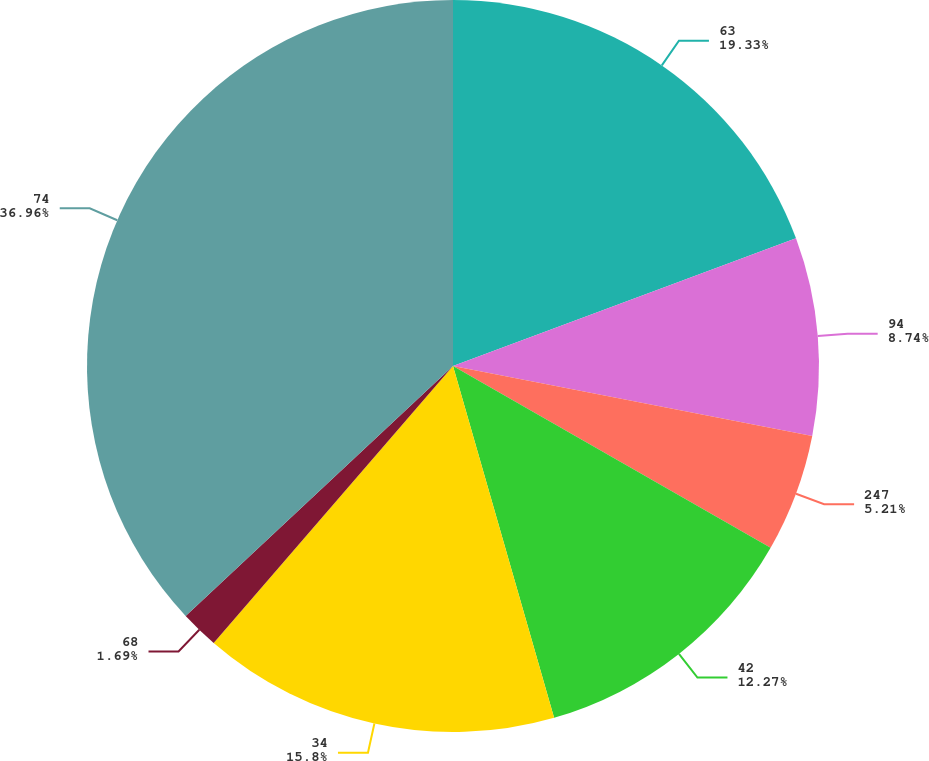Convert chart to OTSL. <chart><loc_0><loc_0><loc_500><loc_500><pie_chart><fcel>63<fcel>94<fcel>247<fcel>42<fcel>34<fcel>68<fcel>74<nl><fcel>19.33%<fcel>8.74%<fcel>5.21%<fcel>12.27%<fcel>15.8%<fcel>1.69%<fcel>36.97%<nl></chart> 